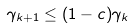Convert formula to latex. <formula><loc_0><loc_0><loc_500><loc_500>\gamma _ { k + 1 } \leq ( 1 - c ) \gamma _ { k }</formula> 